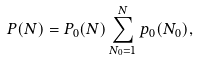<formula> <loc_0><loc_0><loc_500><loc_500>P ( N ) = P _ { 0 } ( N ) \sum _ { N _ { 0 } = 1 } ^ { N } { p _ { 0 } ( N _ { 0 } ) } ,</formula> 